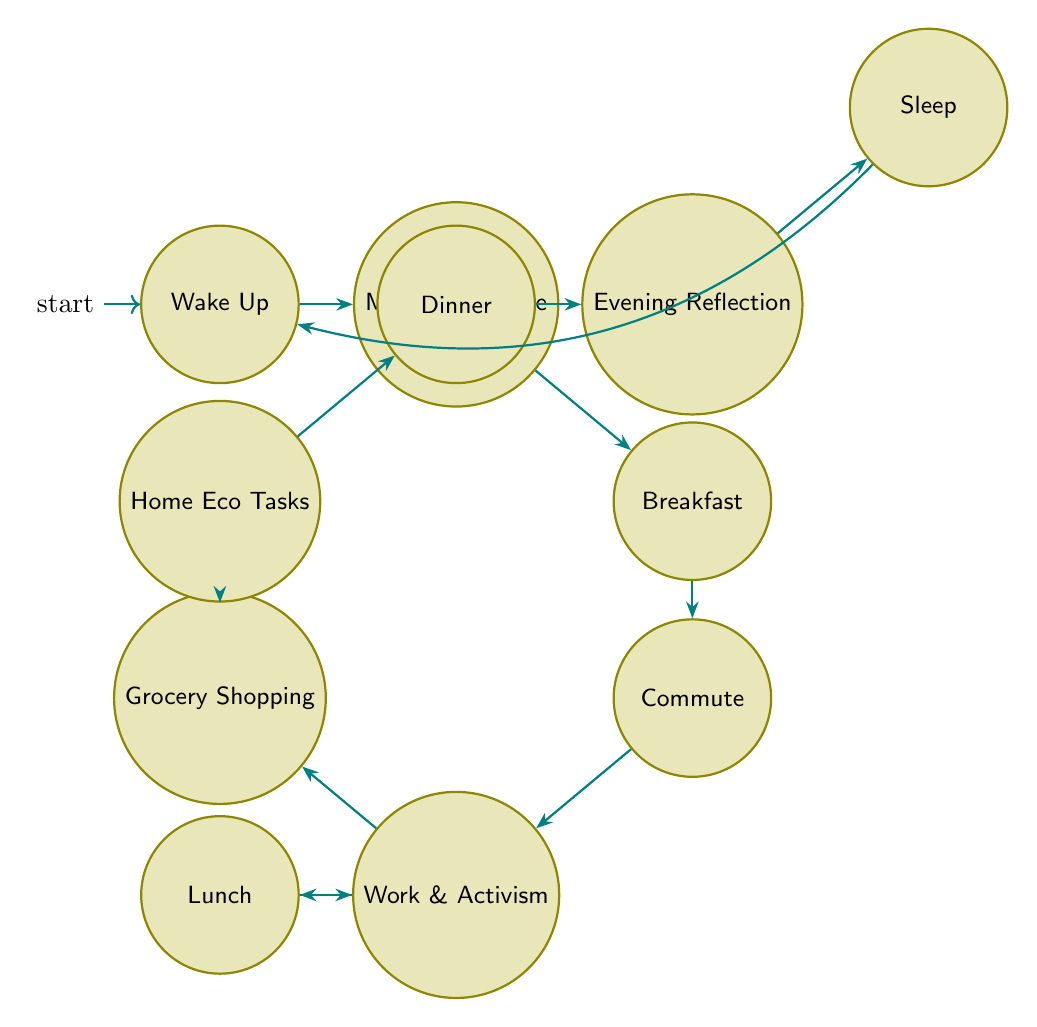What is the first state of the routine? The diagram shows that the first state is "Wake Up," which is the starting point of the daily routine.
Answer: Wake Up How many states are there in total? By counting the nodes represented in the diagram, there are eleven states that depict various parts of the zero-waste living routine.
Answer: 11 What comes after "Lunch"? According to the diagram, the transition after "Lunch" goes back to "Work Activism" as indicated by the directed edge connecting these states.
Answer: Work Activism Which state involves preparing a meal? The state "Breakfast" in the diagram is specifically described as preparing a meal, highlighting its significance in the routine.
Answer: Breakfast Which two states are connected by the same transition? "Work Activism" connects to "Lunch" as well as "Grocery Shopping," sharing the transition from the same starting point (Work Activism) to two different outcomes in the routine.
Answer: Lunch and Grocery Shopping What is the last state before the routine resets? The final state before returning to the beginning is "Sleep," indicating the end of the daily cycle and the process of preparing for another day.
Answer: Sleep What activity is associated with "Grocery Shopping"? The state "Grocery Shopping" describes the action of visiting a farmer's market with cloth bags and glass jars, emphasizing the zero-waste approach.
Answer: Visiting a farmer's market In which state does reflection take place? The state dedicated to reflection is "Evening Reflection," where the individual considers the day's activities and plans for more sustainable practices.
Answer: Evening Reflection How does one transition from "Commute" to "Work Activism"? The transition is direct as indicated by the edge leading from "Commute" to "Work Activism," showcasing the flow of the routine.
Answer: Work Activism 